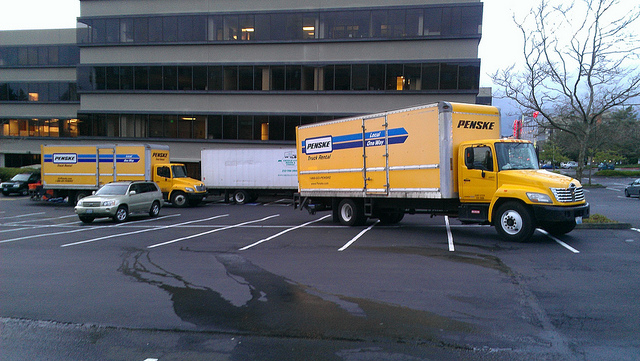Read all the text in this image. PENSKY PENSKE 